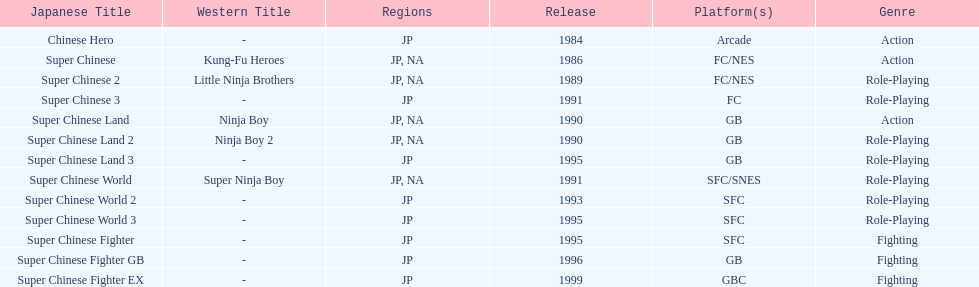Quantity of super chinese worldwide games published 3. 